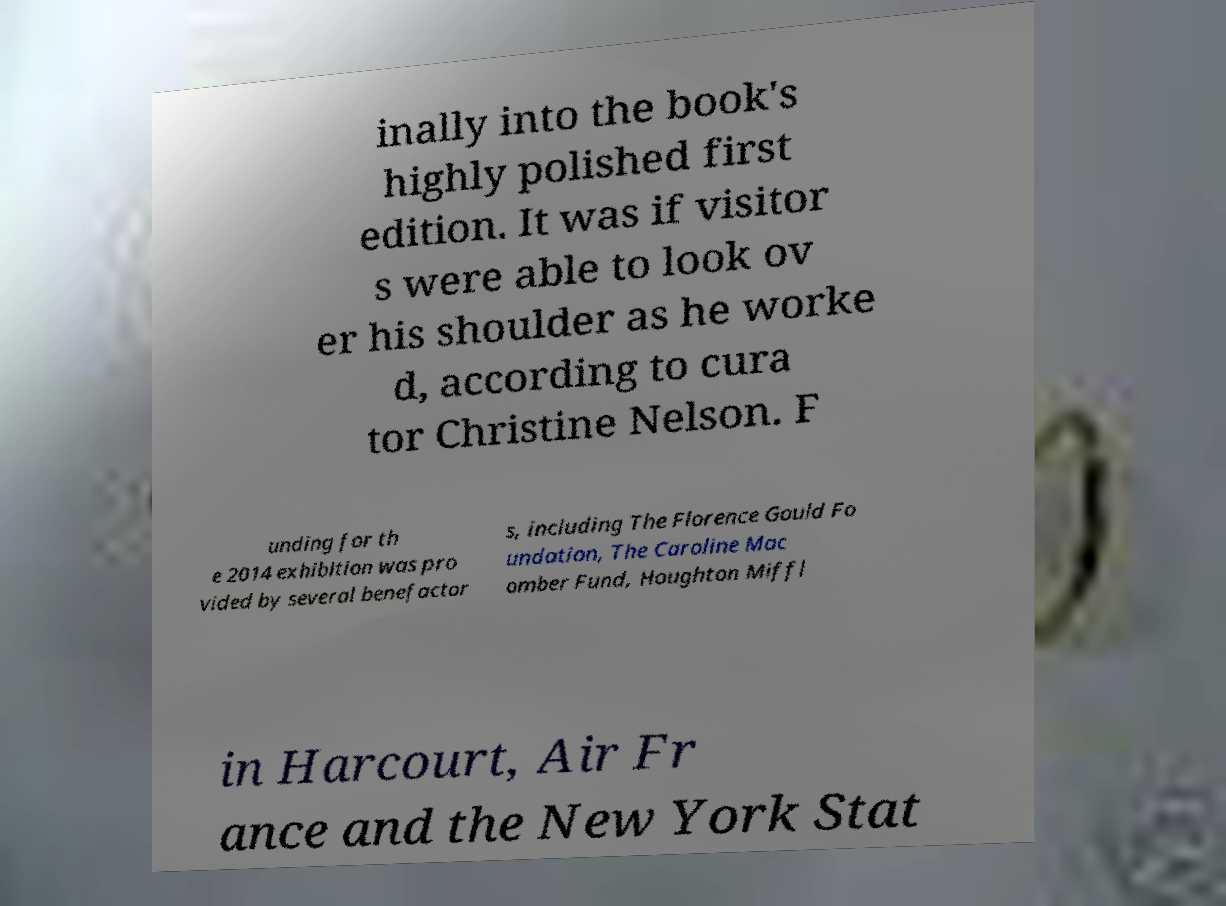Could you extract and type out the text from this image? inally into the book's highly polished first edition. It was if visitor s were able to look ov er his shoulder as he worke d, according to cura tor Christine Nelson. F unding for th e 2014 exhibition was pro vided by several benefactor s, including The Florence Gould Fo undation, The Caroline Mac omber Fund, Houghton Miffl in Harcourt, Air Fr ance and the New York Stat 